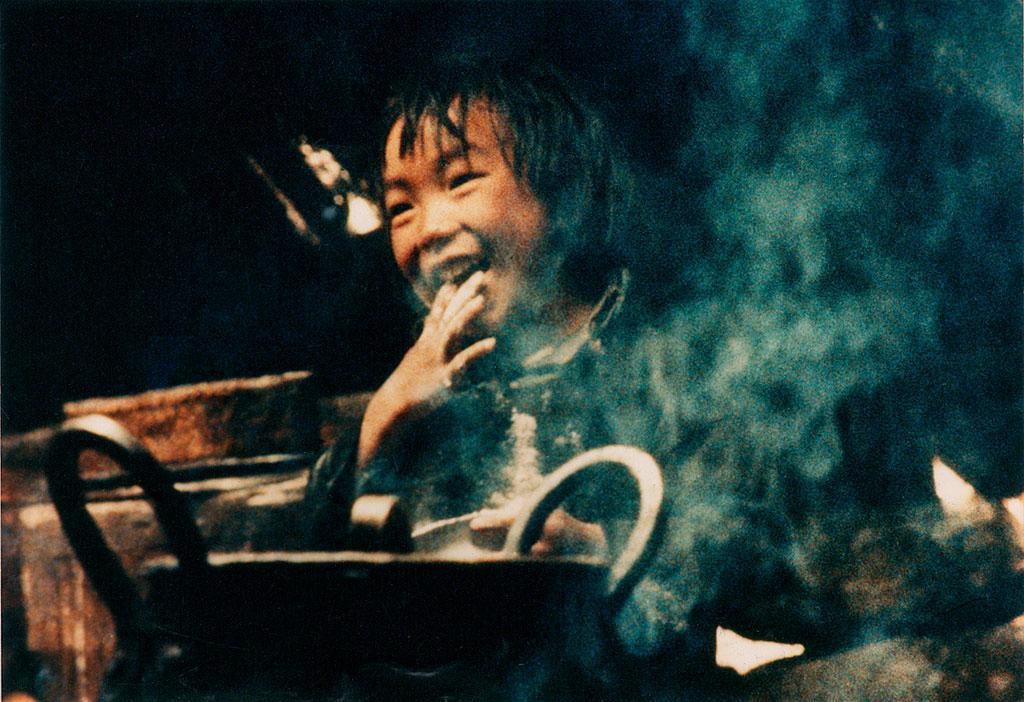Could you give a brief overview of what you see in this image? In this picture I can see a utensil in front and I see the smoke and I see a child who is smiling and I see that it is dark in the background. 